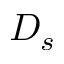<formula> <loc_0><loc_0><loc_500><loc_500>D _ { s }</formula> 